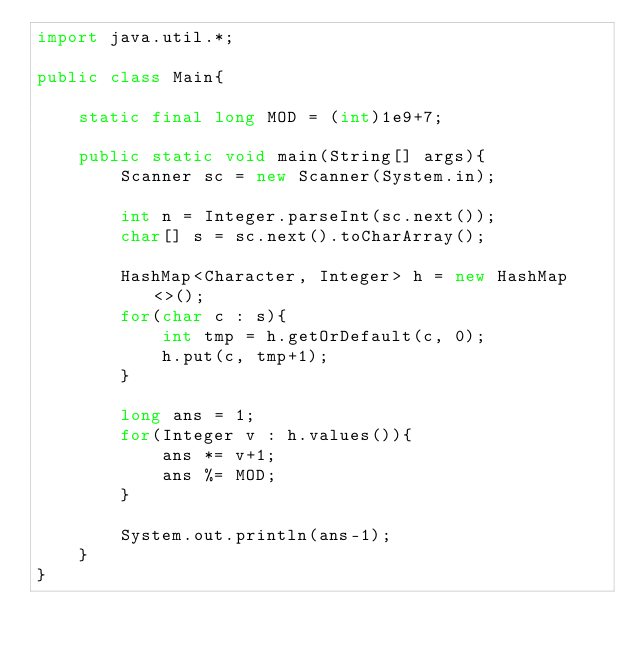<code> <loc_0><loc_0><loc_500><loc_500><_Java_>import java.util.*;

public class Main{
    
    static final long MOD = (int)1e9+7;
    
    public static void main(String[] args){
        Scanner sc = new Scanner(System.in);
        
        int n = Integer.parseInt(sc.next());
        char[] s = sc.next().toCharArray();
        
        HashMap<Character, Integer> h = new HashMap<>();
        for(char c : s){
            int tmp = h.getOrDefault(c, 0);
            h.put(c, tmp+1);
        }
        
        long ans = 1;
        for(Integer v : h.values()){
            ans *= v+1;
            ans %= MOD;
        }
        
        System.out.println(ans-1);
    }
}</code> 